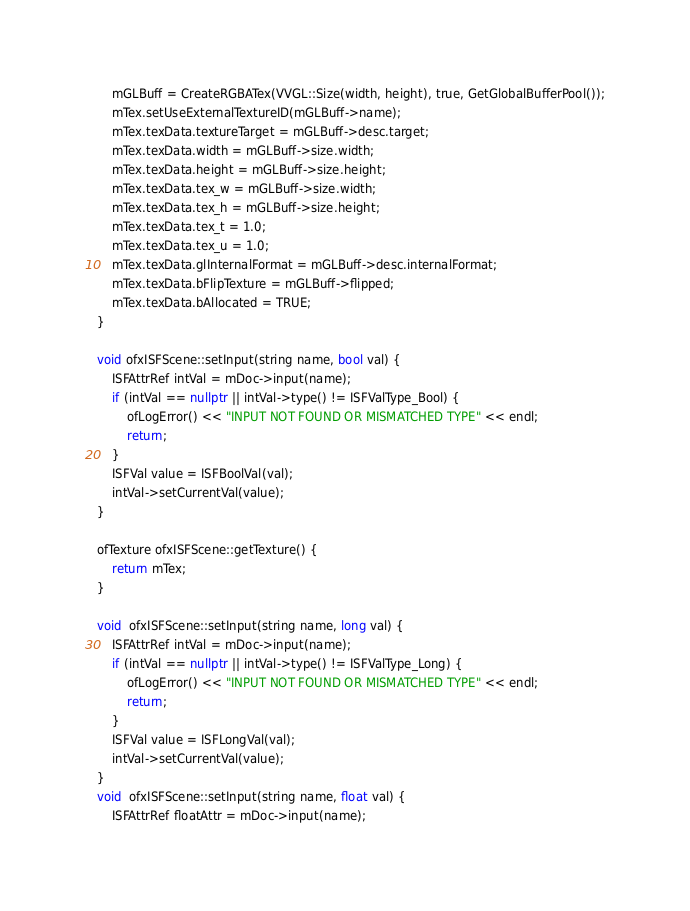Convert code to text. <code><loc_0><loc_0><loc_500><loc_500><_C++_>	mGLBuff = CreateRGBATex(VVGL::Size(width, height), true, GetGlobalBufferPool());
	mTex.setUseExternalTextureID(mGLBuff->name);
	mTex.texData.textureTarget = mGLBuff->desc.target;
	mTex.texData.width = mGLBuff->size.width;
	mTex.texData.height = mGLBuff->size.height;
	mTex.texData.tex_w = mGLBuff->size.width;
	mTex.texData.tex_h = mGLBuff->size.height;
	mTex.texData.tex_t = 1.0;
	mTex.texData.tex_u = 1.0;
	mTex.texData.glInternalFormat = mGLBuff->desc.internalFormat;
	mTex.texData.bFlipTexture = mGLBuff->flipped;
	mTex.texData.bAllocated = TRUE;
}

void ofxISFScene::setInput(string name, bool val) {
	ISFAttrRef intVal = mDoc->input(name);
	if (intVal == nullptr || intVal->type() != ISFValType_Bool) {
		ofLogError() << "INPUT NOT FOUND OR MISMATCHED TYPE" << endl;
		return;
	}
	ISFVal value = ISFBoolVal(val);
	intVal->setCurrentVal(value);
}

ofTexture ofxISFScene::getTexture() {
	return mTex;
}

void  ofxISFScene::setInput(string name, long val) {
	ISFAttrRef intVal = mDoc->input(name);
	if (intVal == nullptr || intVal->type() != ISFValType_Long) {
		ofLogError() << "INPUT NOT FOUND OR MISMATCHED TYPE" << endl;
		return;
	}
	ISFVal value = ISFLongVal(val);
	intVal->setCurrentVal(value);
}
void  ofxISFScene::setInput(string name, float val) {
	ISFAttrRef floatAttr = mDoc->input(name);</code> 